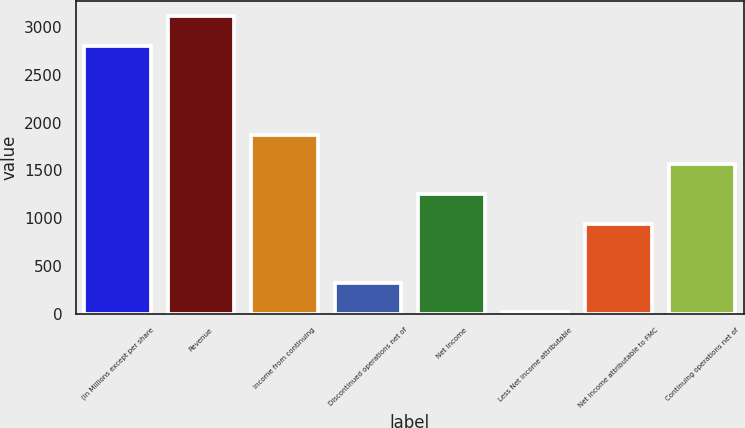Convert chart to OTSL. <chart><loc_0><loc_0><loc_500><loc_500><bar_chart><fcel>(in Millions except per share<fcel>Revenue<fcel>Income from continuing<fcel>Discontinued operations net of<fcel>Net income<fcel>Less Net income attributable<fcel>Net income attributable to FMC<fcel>Continuing operations net of<nl><fcel>2805.91<fcel>3116.3<fcel>1874.74<fcel>322.79<fcel>1253.96<fcel>12.4<fcel>943.57<fcel>1564.35<nl></chart> 